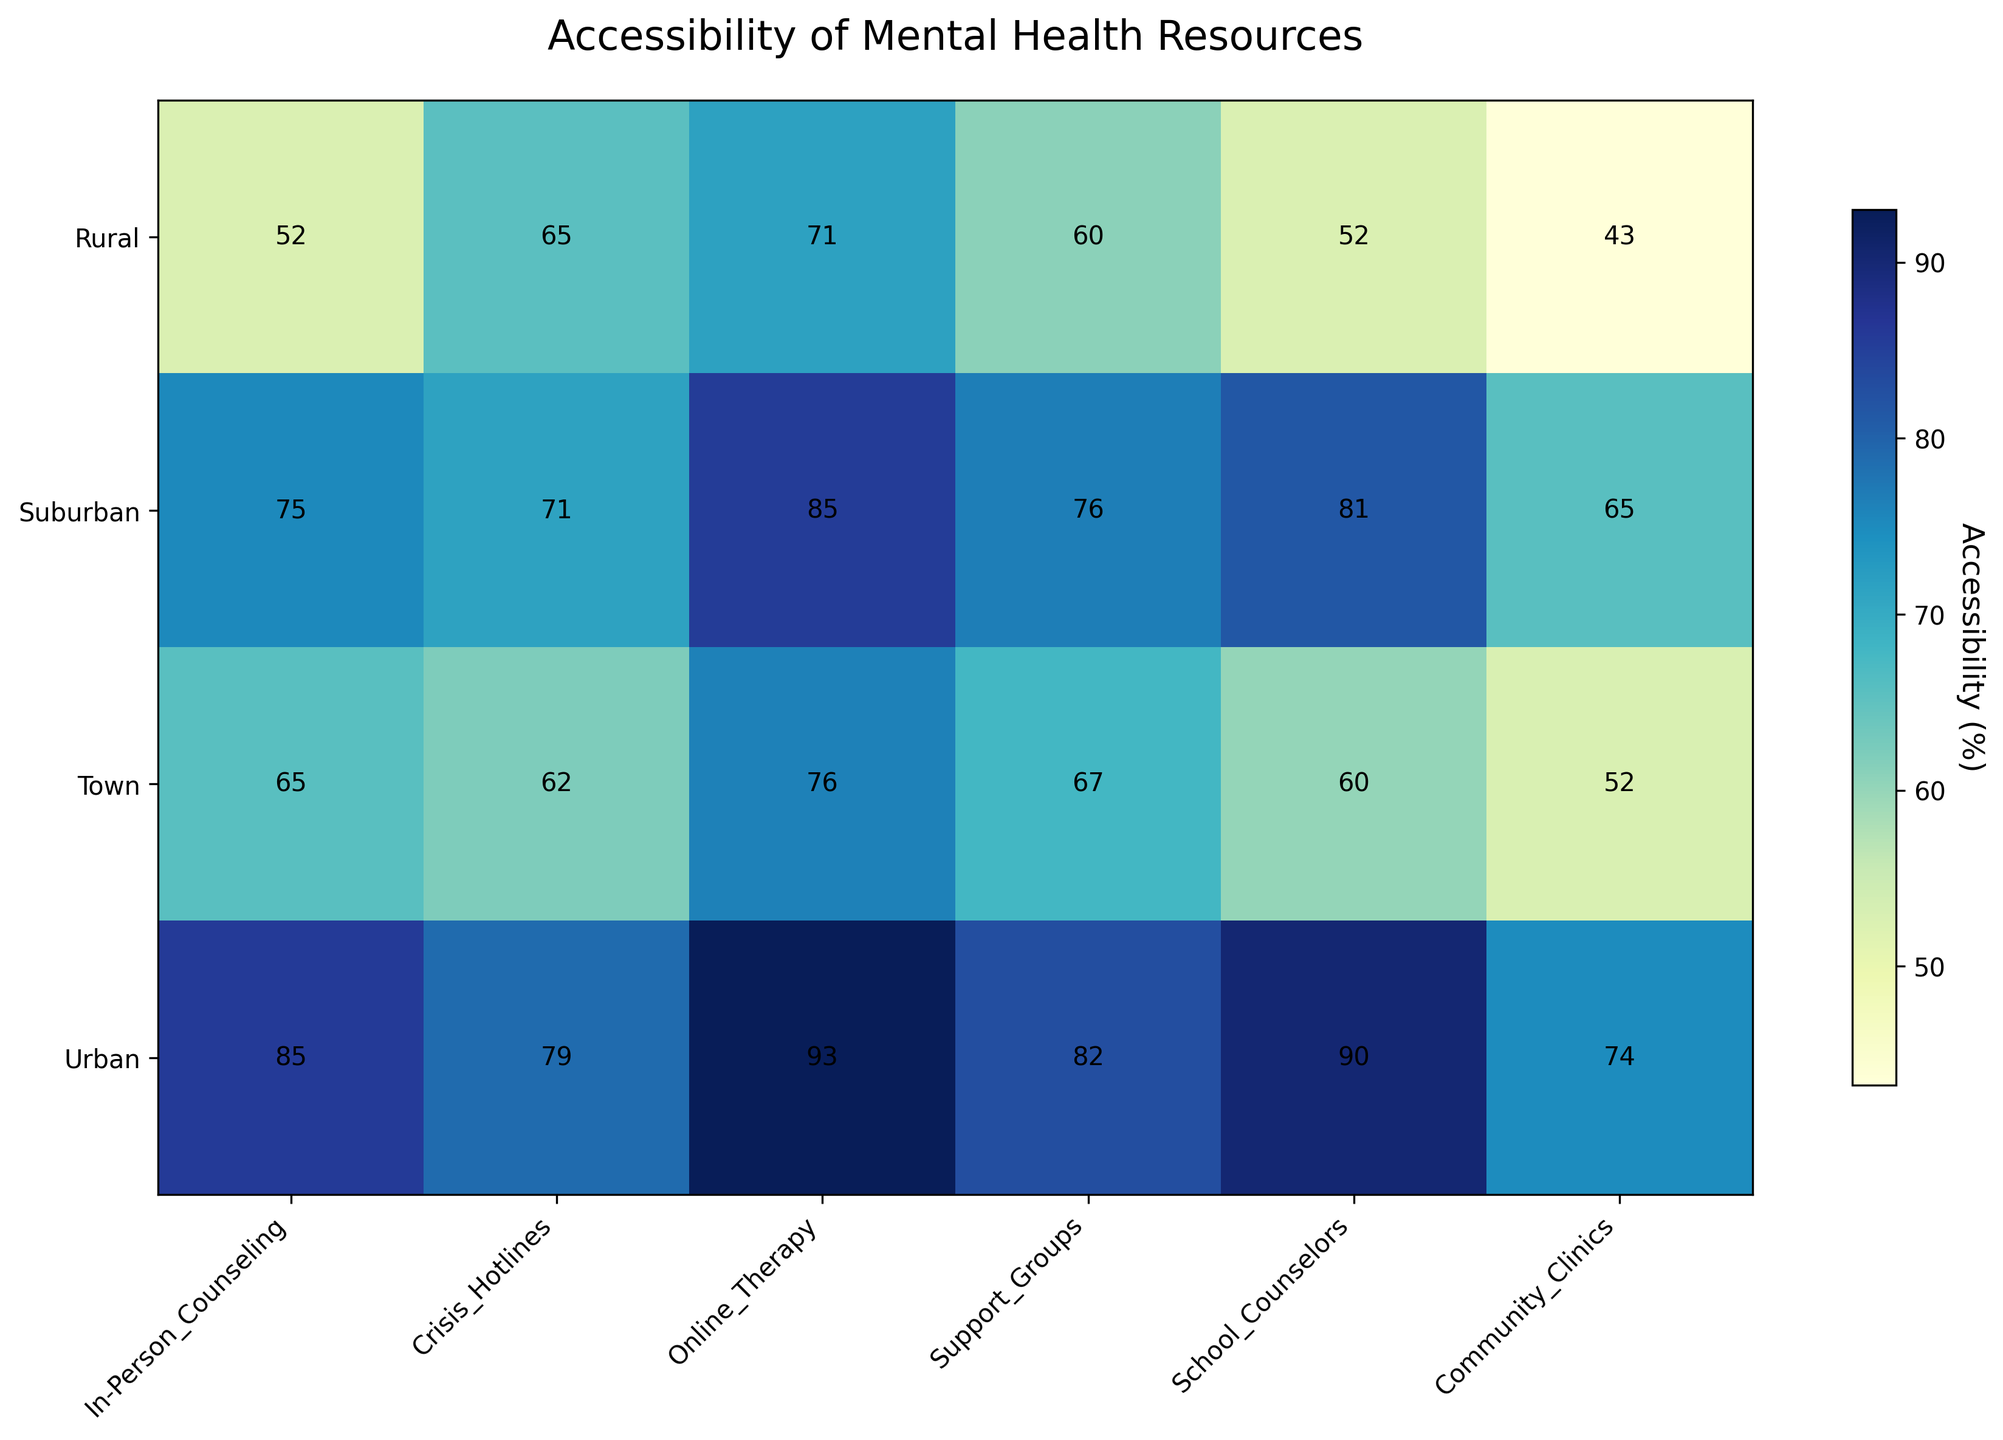Which geographic location has the highest accessibility to in-person counseling? Notice the higher numbers or shading in terms of accessibility for in-person counseling in the heatmap. The urban area shows the darkest shade with the highest values.
Answer: Urban How does the accessibility of community clinics in suburban areas compare to that in rural areas? Compare the numeric values or relative shading for community clinics between suburban and rural areas. Suburban areas show higher accessibility (values around 64-70) compared to rural areas (values around 40-46).
Answer: Higher in suburban areas Which type of mental health resource has the most consistent accessibility across all geographic locations? Look for columns where the values are most similar across different geographic locations. Online therapy values seem consistently high across different areas such as Urban (around 90-95) and Suburban (around 87-88).
Answer: Online Therapy What is the difference in accessibility between crisis hotlines in urban and town areas? Subtract the average value for crisis hotlines in town areas from that in urban areas by visually checking their respective values. Urban has values around 80-83, and Town has values around 60-64, resulting in a difference of around 20-23.
Answer: Around 20-23 Comparing in-person counseling services, which geographic location shows a significant variance from the rural areas? Identify the highest variance by looking at the heatmap for in-person counseling, urban areas show significantly higher values (~85-90) compared to rural areas (~50-55).
Answer: Urban What is the average accessibility of support groups across all geographic locations? Add the values of support groups across Urban, Suburban, Rural, and Town and divide by 4. Average = (80+75+60+65)/4 = 280/4 = 70.
Answer: 70 Which geographic location has the lowest accessibility to school counselors? Find the lowest number in the school counselors column by visually scanning the heatmap. Rural areas show values (~50-55), which are lower than other areas.
Answer: Rural How does the accessibility to mental health resources in the suburban area compare to the urban area overall? Compare the general shading and values across all resources' columns for suburban (~60-85) vs urban (~70-95). Urban areas show overall higher accessibility compared to suburban areas.
Answer: Higher in urban areas 